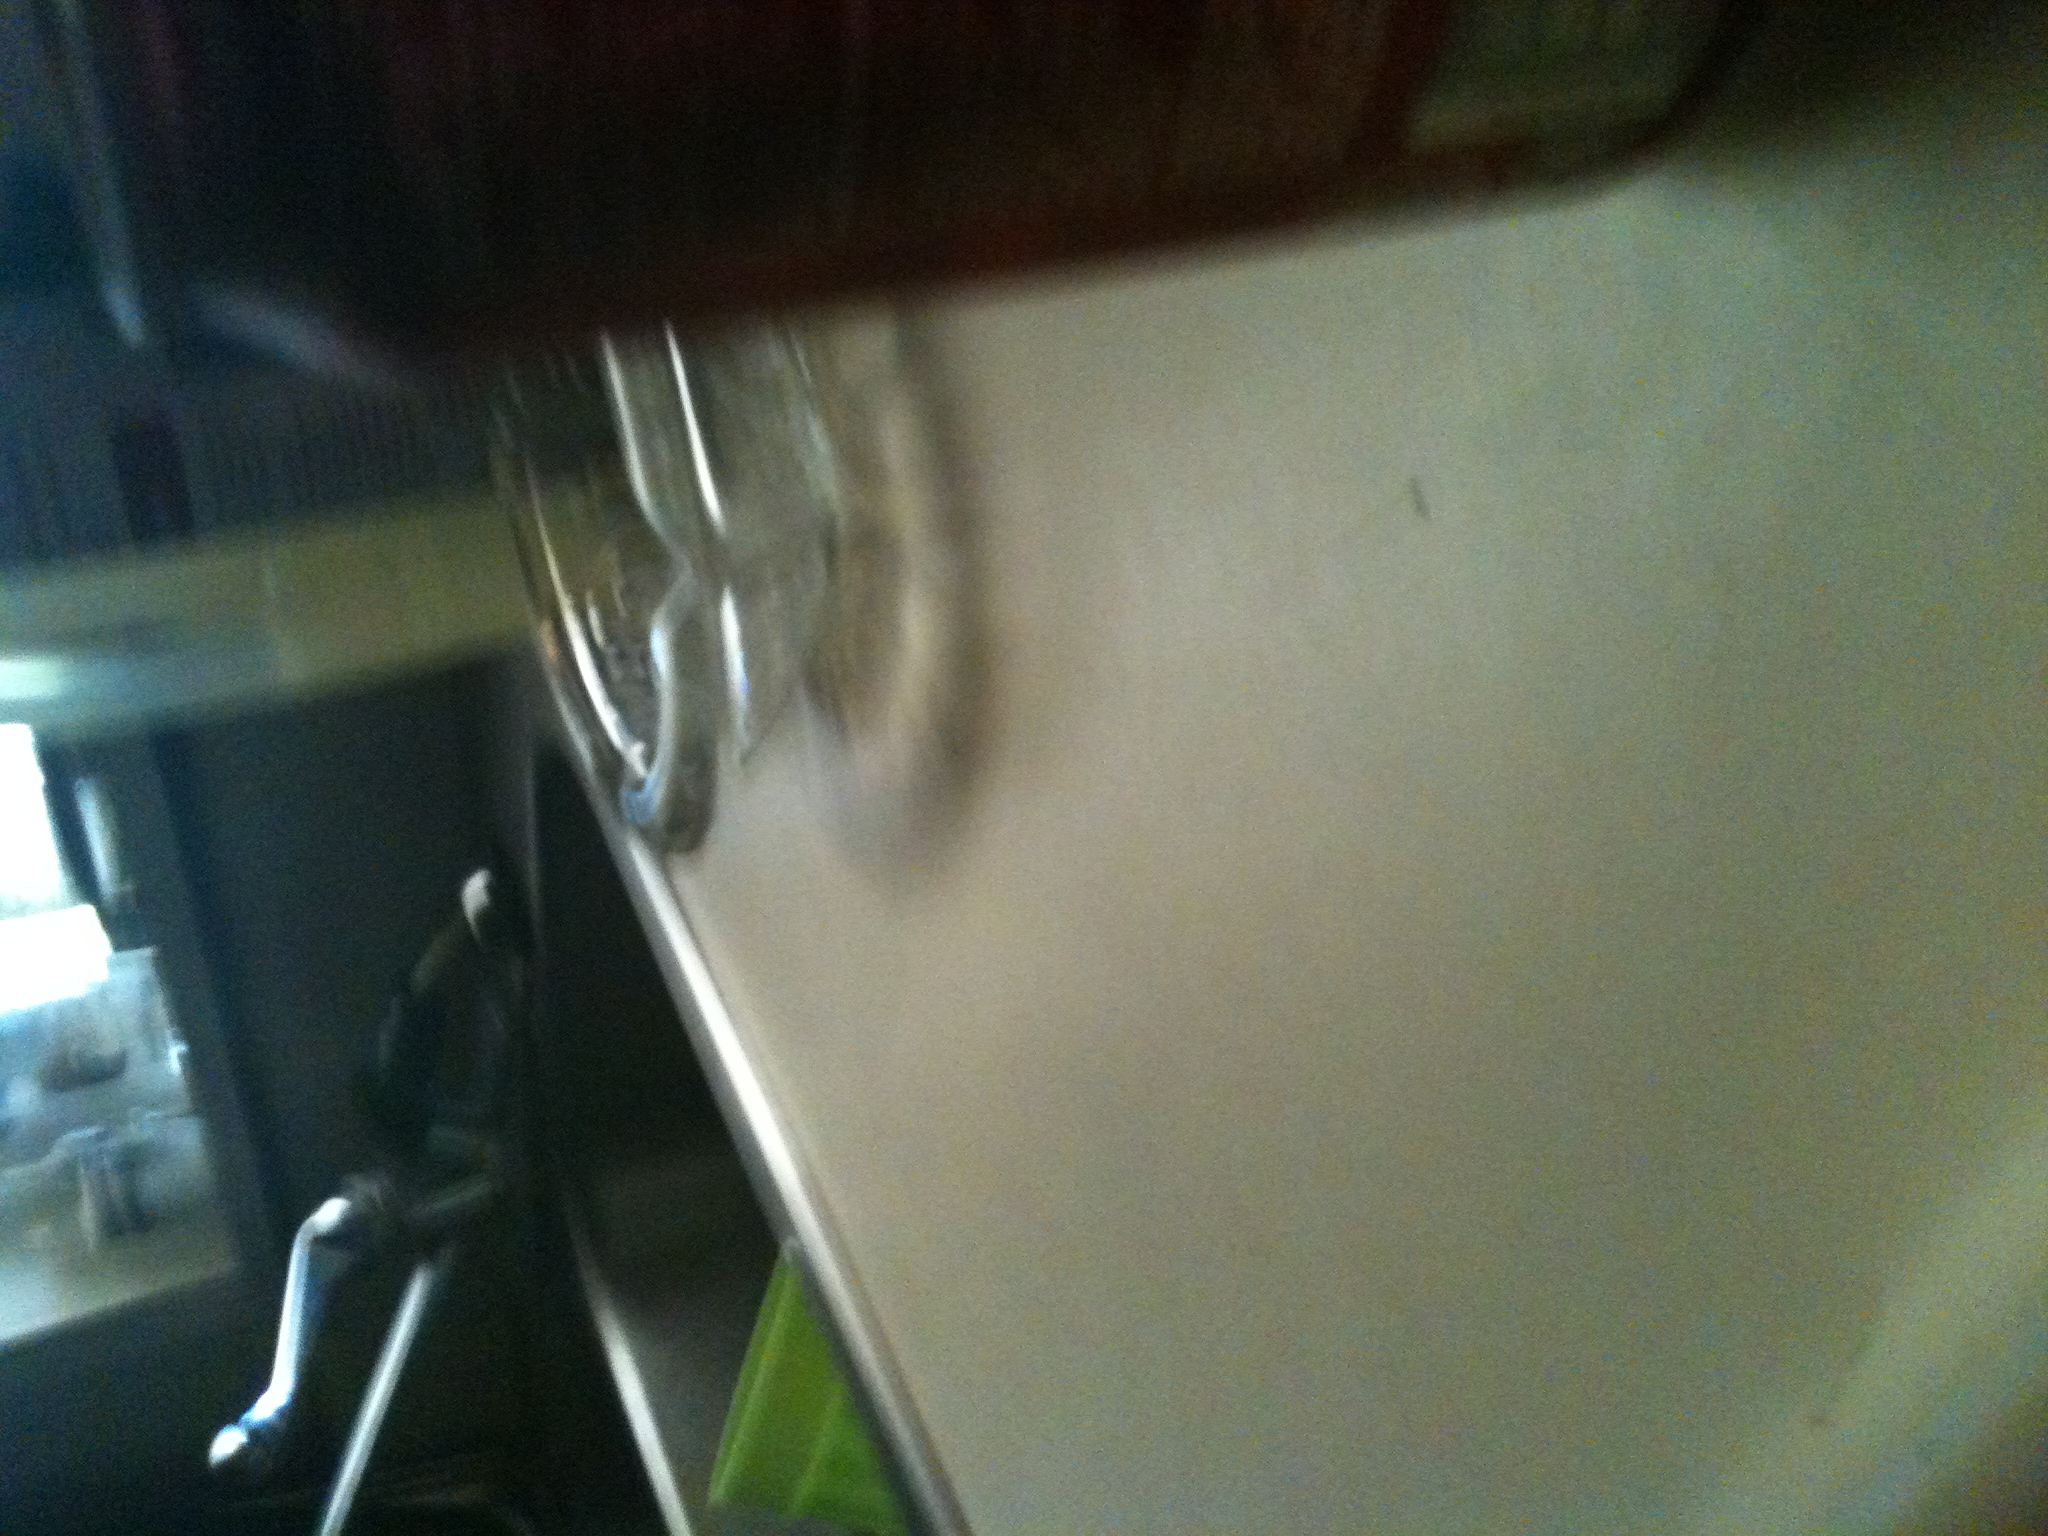What type of setting is this image captured in? The setting appears to be a kitchen, indicated by the presence of a sink, faucet, and typical kitchen countertop materials visible in the somewhat blurred image. 